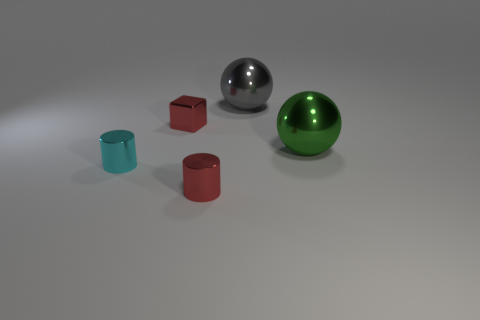Are there the same number of cyan things that are in front of the cyan cylinder and tiny gray rubber things?
Your answer should be compact. Yes. Is there a large sphere that has the same color as the tiny cube?
Give a very brief answer. No. Do the red cylinder and the green object have the same size?
Your answer should be very brief. No. What size is the cyan metal thing left of the large metallic sphere on the left side of the big green ball?
Your answer should be very brief. Small. What size is the metal thing that is to the left of the gray ball and behind the cyan metallic thing?
Give a very brief answer. Small. How many red things have the same size as the red metal cube?
Your response must be concise. 1. How many rubber things are large gray balls or small cylinders?
Offer a terse response. 0. What size is the shiny object that is the same color as the tiny metallic block?
Provide a short and direct response. Small. There is a big object that is in front of the big shiny thing behind the large green object; what is its material?
Your answer should be compact. Metal. How many objects are either green cylinders or big metallic things behind the green metal object?
Give a very brief answer. 1. 